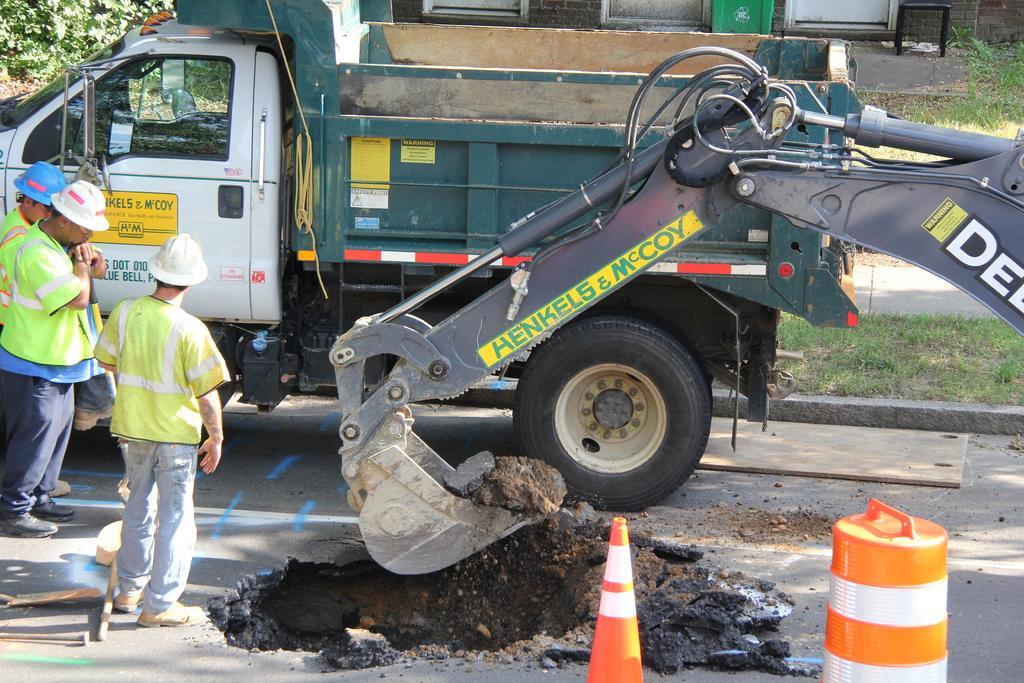How would you summarize this image in a sentence or two? In this picture we can see there are three people standing on the road and on the left side of the people there are some objects. On the right side of the people there is a construction barrel, retractable cone barrier and it looks like a proclainer. Behind the people there is a vehicle, trees, grass and it looks like a house. 